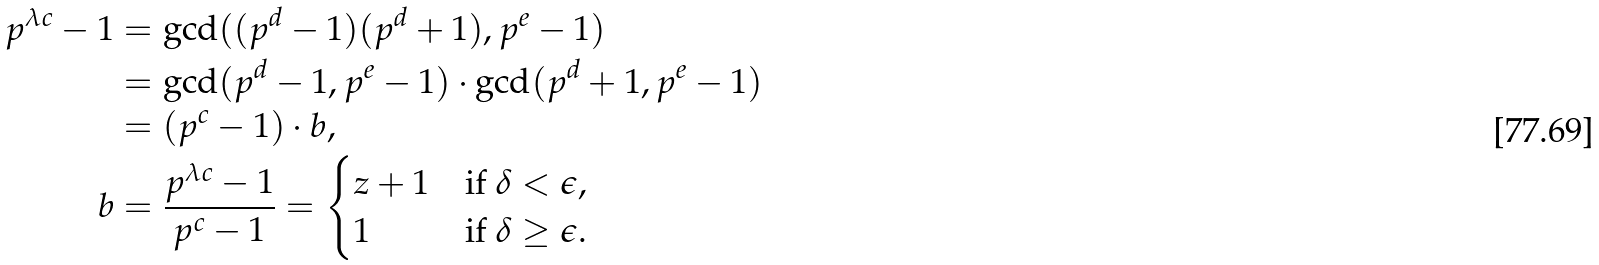<formula> <loc_0><loc_0><loc_500><loc_500>p ^ { \lambda c } - 1 & = \gcd ( ( p ^ { d } - 1 ) ( p ^ { d } + 1 ) , p ^ { e } - 1 ) \\ & = \gcd ( p ^ { d } - 1 , p ^ { e } - 1 ) \cdot \gcd ( p ^ { d } + 1 , p ^ { e } - 1 ) \\ & = ( p ^ { c } - 1 ) \cdot b , \\ b & = \frac { p ^ { \lambda c } - 1 } { p ^ { c } - 1 } = \begin{cases} z + 1 & \text {if } \delta < \epsilon , \\ 1 & \text {if } \delta \geq \epsilon . \end{cases}</formula> 